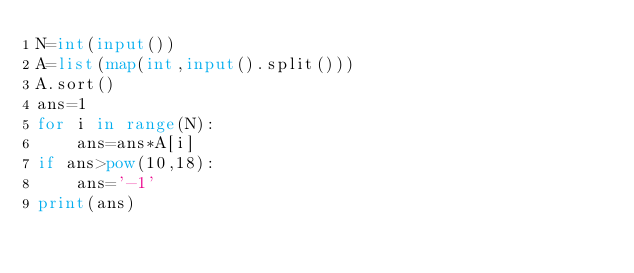<code> <loc_0><loc_0><loc_500><loc_500><_Python_>N=int(input())
A=list(map(int,input().split()))
A.sort()
ans=1
for i in range(N):
    ans=ans*A[i]
if ans>pow(10,18):
    ans='-1'
print(ans)</code> 